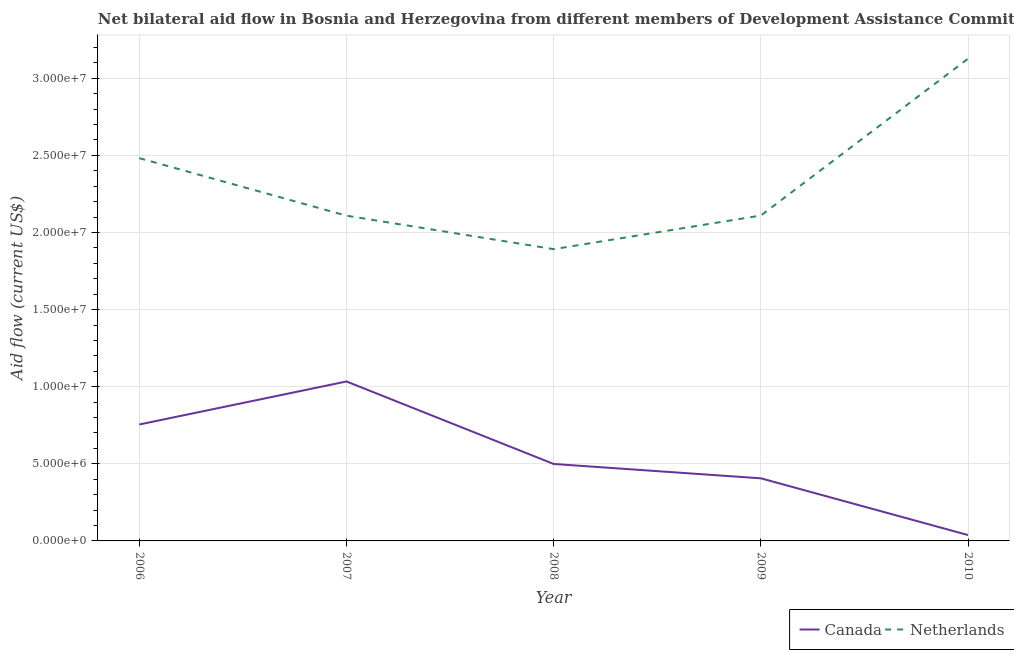Does the line corresponding to amount of aid given by netherlands intersect with the line corresponding to amount of aid given by canada?
Offer a terse response. No. Is the number of lines equal to the number of legend labels?
Offer a terse response. Yes. What is the amount of aid given by netherlands in 2007?
Offer a very short reply. 2.11e+07. Across all years, what is the maximum amount of aid given by netherlands?
Make the answer very short. 3.13e+07. Across all years, what is the minimum amount of aid given by canada?
Keep it short and to the point. 3.80e+05. In which year was the amount of aid given by canada maximum?
Your response must be concise. 2007. In which year was the amount of aid given by netherlands minimum?
Give a very brief answer. 2008. What is the total amount of aid given by netherlands in the graph?
Your answer should be compact. 1.17e+08. What is the difference between the amount of aid given by canada in 2006 and that in 2009?
Ensure brevity in your answer.  3.49e+06. What is the difference between the amount of aid given by canada in 2006 and the amount of aid given by netherlands in 2007?
Keep it short and to the point. -1.35e+07. What is the average amount of aid given by canada per year?
Your response must be concise. 5.46e+06. In the year 2007, what is the difference between the amount of aid given by netherlands and amount of aid given by canada?
Offer a very short reply. 1.08e+07. What is the ratio of the amount of aid given by netherlands in 2009 to that in 2010?
Give a very brief answer. 0.67. What is the difference between the highest and the second highest amount of aid given by netherlands?
Make the answer very short. 6.45e+06. What is the difference between the highest and the lowest amount of aid given by netherlands?
Provide a short and direct response. 1.24e+07. Is the sum of the amount of aid given by netherlands in 2008 and 2009 greater than the maximum amount of aid given by canada across all years?
Keep it short and to the point. Yes. Does the amount of aid given by canada monotonically increase over the years?
Keep it short and to the point. No. Is the amount of aid given by canada strictly greater than the amount of aid given by netherlands over the years?
Your response must be concise. No. How many years are there in the graph?
Ensure brevity in your answer.  5. Are the values on the major ticks of Y-axis written in scientific E-notation?
Offer a very short reply. Yes. Does the graph contain any zero values?
Provide a succinct answer. No. Where does the legend appear in the graph?
Ensure brevity in your answer.  Bottom right. How many legend labels are there?
Your answer should be compact. 2. What is the title of the graph?
Ensure brevity in your answer.  Net bilateral aid flow in Bosnia and Herzegovina from different members of Development Assistance Committee. What is the label or title of the X-axis?
Your answer should be compact. Year. What is the Aid flow (current US$) in Canada in 2006?
Make the answer very short. 7.55e+06. What is the Aid flow (current US$) in Netherlands in 2006?
Your answer should be very brief. 2.48e+07. What is the Aid flow (current US$) in Canada in 2007?
Make the answer very short. 1.03e+07. What is the Aid flow (current US$) of Netherlands in 2007?
Offer a terse response. 2.11e+07. What is the Aid flow (current US$) in Canada in 2008?
Your answer should be very brief. 4.99e+06. What is the Aid flow (current US$) in Netherlands in 2008?
Your answer should be compact. 1.89e+07. What is the Aid flow (current US$) of Canada in 2009?
Provide a short and direct response. 4.06e+06. What is the Aid flow (current US$) in Netherlands in 2009?
Your answer should be very brief. 2.11e+07. What is the Aid flow (current US$) in Netherlands in 2010?
Your response must be concise. 3.13e+07. Across all years, what is the maximum Aid flow (current US$) of Canada?
Give a very brief answer. 1.03e+07. Across all years, what is the maximum Aid flow (current US$) of Netherlands?
Offer a very short reply. 3.13e+07. Across all years, what is the minimum Aid flow (current US$) of Netherlands?
Provide a short and direct response. 1.89e+07. What is the total Aid flow (current US$) of Canada in the graph?
Provide a short and direct response. 2.73e+07. What is the total Aid flow (current US$) in Netherlands in the graph?
Provide a succinct answer. 1.17e+08. What is the difference between the Aid flow (current US$) of Canada in 2006 and that in 2007?
Offer a very short reply. -2.79e+06. What is the difference between the Aid flow (current US$) in Netherlands in 2006 and that in 2007?
Your response must be concise. 3.73e+06. What is the difference between the Aid flow (current US$) of Canada in 2006 and that in 2008?
Your response must be concise. 2.56e+06. What is the difference between the Aid flow (current US$) of Netherlands in 2006 and that in 2008?
Provide a short and direct response. 5.90e+06. What is the difference between the Aid flow (current US$) in Canada in 2006 and that in 2009?
Provide a succinct answer. 3.49e+06. What is the difference between the Aid flow (current US$) in Netherlands in 2006 and that in 2009?
Your answer should be compact. 3.72e+06. What is the difference between the Aid flow (current US$) in Canada in 2006 and that in 2010?
Keep it short and to the point. 7.17e+06. What is the difference between the Aid flow (current US$) of Netherlands in 2006 and that in 2010?
Provide a succinct answer. -6.45e+06. What is the difference between the Aid flow (current US$) in Canada in 2007 and that in 2008?
Provide a succinct answer. 5.35e+06. What is the difference between the Aid flow (current US$) in Netherlands in 2007 and that in 2008?
Your answer should be very brief. 2.17e+06. What is the difference between the Aid flow (current US$) in Canada in 2007 and that in 2009?
Your answer should be very brief. 6.28e+06. What is the difference between the Aid flow (current US$) of Canada in 2007 and that in 2010?
Provide a succinct answer. 9.96e+06. What is the difference between the Aid flow (current US$) in Netherlands in 2007 and that in 2010?
Make the answer very short. -1.02e+07. What is the difference between the Aid flow (current US$) of Canada in 2008 and that in 2009?
Provide a short and direct response. 9.30e+05. What is the difference between the Aid flow (current US$) of Netherlands in 2008 and that in 2009?
Your answer should be very brief. -2.18e+06. What is the difference between the Aid flow (current US$) of Canada in 2008 and that in 2010?
Offer a very short reply. 4.61e+06. What is the difference between the Aid flow (current US$) in Netherlands in 2008 and that in 2010?
Ensure brevity in your answer.  -1.24e+07. What is the difference between the Aid flow (current US$) of Canada in 2009 and that in 2010?
Offer a terse response. 3.68e+06. What is the difference between the Aid flow (current US$) in Netherlands in 2009 and that in 2010?
Your answer should be very brief. -1.02e+07. What is the difference between the Aid flow (current US$) of Canada in 2006 and the Aid flow (current US$) of Netherlands in 2007?
Provide a short and direct response. -1.35e+07. What is the difference between the Aid flow (current US$) of Canada in 2006 and the Aid flow (current US$) of Netherlands in 2008?
Make the answer very short. -1.14e+07. What is the difference between the Aid flow (current US$) of Canada in 2006 and the Aid flow (current US$) of Netherlands in 2009?
Offer a terse response. -1.36e+07. What is the difference between the Aid flow (current US$) of Canada in 2006 and the Aid flow (current US$) of Netherlands in 2010?
Provide a succinct answer. -2.37e+07. What is the difference between the Aid flow (current US$) in Canada in 2007 and the Aid flow (current US$) in Netherlands in 2008?
Your response must be concise. -8.58e+06. What is the difference between the Aid flow (current US$) in Canada in 2007 and the Aid flow (current US$) in Netherlands in 2009?
Your response must be concise. -1.08e+07. What is the difference between the Aid flow (current US$) of Canada in 2007 and the Aid flow (current US$) of Netherlands in 2010?
Provide a short and direct response. -2.09e+07. What is the difference between the Aid flow (current US$) of Canada in 2008 and the Aid flow (current US$) of Netherlands in 2009?
Make the answer very short. -1.61e+07. What is the difference between the Aid flow (current US$) of Canada in 2008 and the Aid flow (current US$) of Netherlands in 2010?
Your response must be concise. -2.63e+07. What is the difference between the Aid flow (current US$) in Canada in 2009 and the Aid flow (current US$) in Netherlands in 2010?
Provide a short and direct response. -2.72e+07. What is the average Aid flow (current US$) of Canada per year?
Offer a terse response. 5.46e+06. What is the average Aid flow (current US$) of Netherlands per year?
Your response must be concise. 2.34e+07. In the year 2006, what is the difference between the Aid flow (current US$) of Canada and Aid flow (current US$) of Netherlands?
Offer a terse response. -1.73e+07. In the year 2007, what is the difference between the Aid flow (current US$) of Canada and Aid flow (current US$) of Netherlands?
Offer a terse response. -1.08e+07. In the year 2008, what is the difference between the Aid flow (current US$) of Canada and Aid flow (current US$) of Netherlands?
Provide a succinct answer. -1.39e+07. In the year 2009, what is the difference between the Aid flow (current US$) in Canada and Aid flow (current US$) in Netherlands?
Give a very brief answer. -1.70e+07. In the year 2010, what is the difference between the Aid flow (current US$) of Canada and Aid flow (current US$) of Netherlands?
Give a very brief answer. -3.09e+07. What is the ratio of the Aid flow (current US$) in Canada in 2006 to that in 2007?
Ensure brevity in your answer.  0.73. What is the ratio of the Aid flow (current US$) of Netherlands in 2006 to that in 2007?
Make the answer very short. 1.18. What is the ratio of the Aid flow (current US$) in Canada in 2006 to that in 2008?
Provide a succinct answer. 1.51. What is the ratio of the Aid flow (current US$) of Netherlands in 2006 to that in 2008?
Offer a terse response. 1.31. What is the ratio of the Aid flow (current US$) of Canada in 2006 to that in 2009?
Provide a succinct answer. 1.86. What is the ratio of the Aid flow (current US$) of Netherlands in 2006 to that in 2009?
Offer a very short reply. 1.18. What is the ratio of the Aid flow (current US$) of Canada in 2006 to that in 2010?
Your response must be concise. 19.87. What is the ratio of the Aid flow (current US$) of Netherlands in 2006 to that in 2010?
Make the answer very short. 0.79. What is the ratio of the Aid flow (current US$) of Canada in 2007 to that in 2008?
Make the answer very short. 2.07. What is the ratio of the Aid flow (current US$) of Netherlands in 2007 to that in 2008?
Ensure brevity in your answer.  1.11. What is the ratio of the Aid flow (current US$) in Canada in 2007 to that in 2009?
Offer a very short reply. 2.55. What is the ratio of the Aid flow (current US$) in Netherlands in 2007 to that in 2009?
Your answer should be compact. 1. What is the ratio of the Aid flow (current US$) of Canada in 2007 to that in 2010?
Your answer should be very brief. 27.21. What is the ratio of the Aid flow (current US$) in Netherlands in 2007 to that in 2010?
Your answer should be very brief. 0.67. What is the ratio of the Aid flow (current US$) of Canada in 2008 to that in 2009?
Provide a succinct answer. 1.23. What is the ratio of the Aid flow (current US$) of Netherlands in 2008 to that in 2009?
Ensure brevity in your answer.  0.9. What is the ratio of the Aid flow (current US$) in Canada in 2008 to that in 2010?
Your response must be concise. 13.13. What is the ratio of the Aid flow (current US$) in Netherlands in 2008 to that in 2010?
Offer a terse response. 0.61. What is the ratio of the Aid flow (current US$) of Canada in 2009 to that in 2010?
Keep it short and to the point. 10.68. What is the ratio of the Aid flow (current US$) of Netherlands in 2009 to that in 2010?
Your answer should be very brief. 0.67. What is the difference between the highest and the second highest Aid flow (current US$) of Canada?
Make the answer very short. 2.79e+06. What is the difference between the highest and the second highest Aid flow (current US$) in Netherlands?
Ensure brevity in your answer.  6.45e+06. What is the difference between the highest and the lowest Aid flow (current US$) in Canada?
Your response must be concise. 9.96e+06. What is the difference between the highest and the lowest Aid flow (current US$) in Netherlands?
Ensure brevity in your answer.  1.24e+07. 